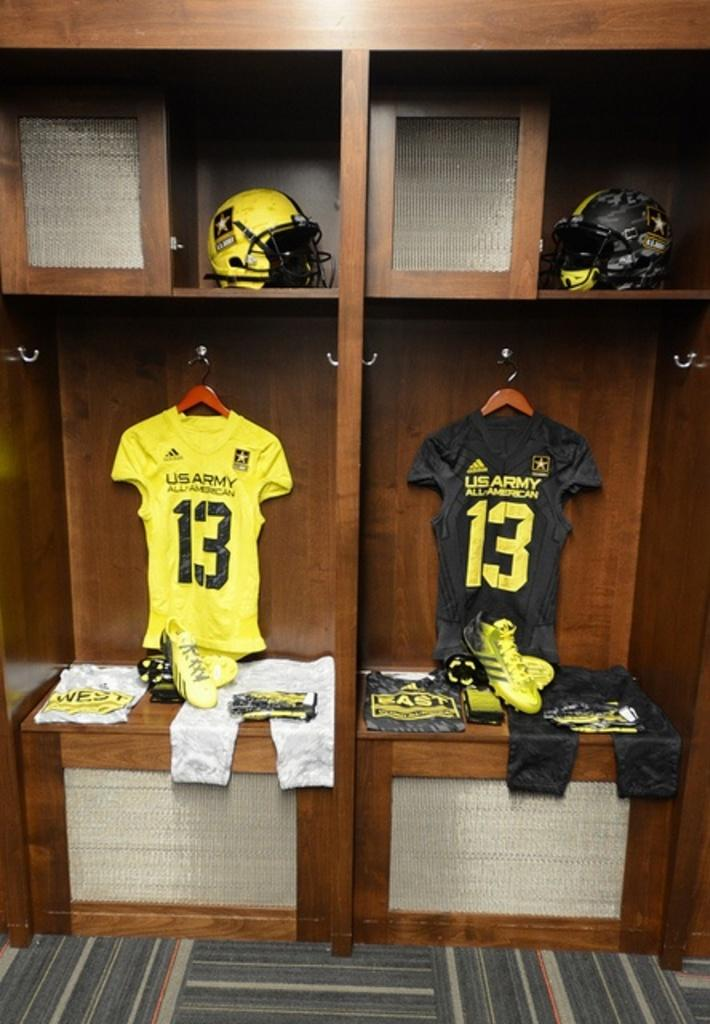<image>
Relay a brief, clear account of the picture shown. Two football lockers that are next to each other are perfectly organized, both with jersey's hanging up that say U.S. Army on the back. 